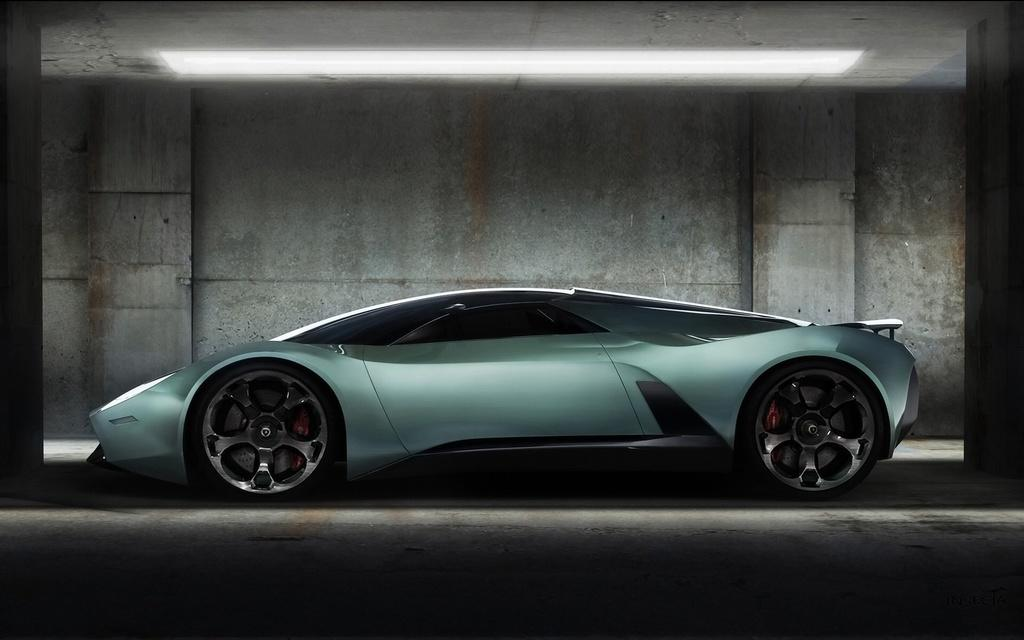What is the main subject of the image? There is a car in the image. Where is the car located? The car is parked in a parking lot. What else can be seen in the image besides the car? There is a wall and pillars in the image. What part of a building is visible at the top of the image? The ceiling of a building is visible at the top of the image. What type of theory is being discussed in the bedroom in the image? There is no bedroom present in the image, and therefore no discussion of any theory can be observed. 